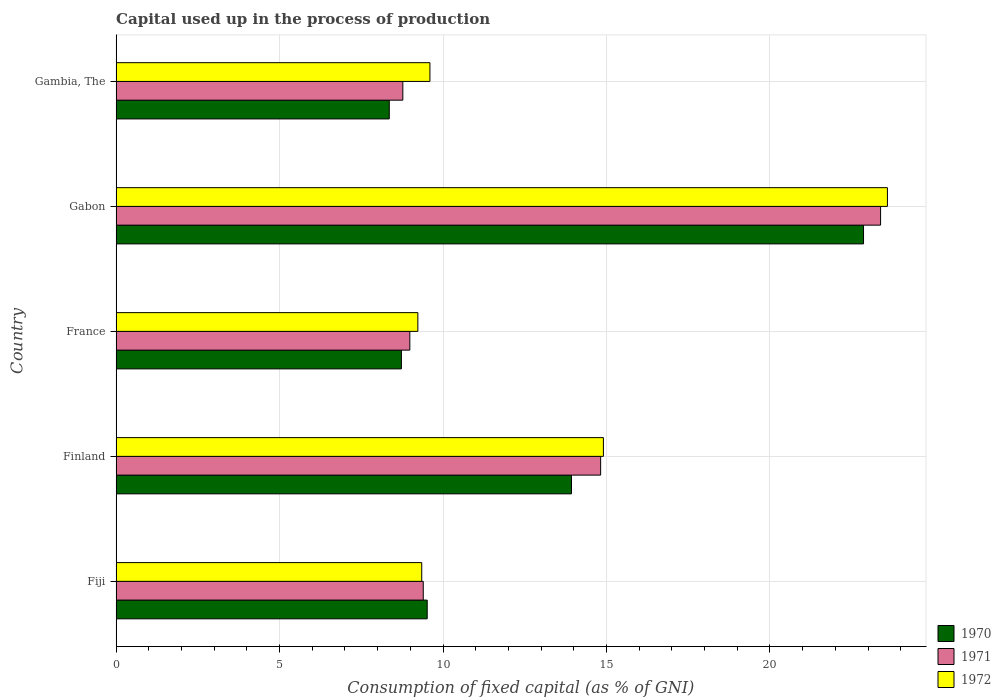How many different coloured bars are there?
Give a very brief answer. 3. Are the number of bars on each tick of the Y-axis equal?
Your response must be concise. Yes. How many bars are there on the 4th tick from the top?
Your response must be concise. 3. What is the label of the 5th group of bars from the top?
Your answer should be compact. Fiji. What is the capital used up in the process of production in 1971 in Gambia, The?
Your answer should be very brief. 8.77. Across all countries, what is the maximum capital used up in the process of production in 1970?
Keep it short and to the point. 22.86. Across all countries, what is the minimum capital used up in the process of production in 1972?
Give a very brief answer. 9.23. In which country was the capital used up in the process of production in 1970 maximum?
Make the answer very short. Gabon. In which country was the capital used up in the process of production in 1972 minimum?
Provide a short and direct response. France. What is the total capital used up in the process of production in 1971 in the graph?
Ensure brevity in your answer.  65.35. What is the difference between the capital used up in the process of production in 1970 in Fiji and that in Finland?
Provide a short and direct response. -4.41. What is the difference between the capital used up in the process of production in 1972 in Gabon and the capital used up in the process of production in 1970 in Finland?
Offer a very short reply. 9.66. What is the average capital used up in the process of production in 1970 per country?
Make the answer very short. 12.68. What is the difference between the capital used up in the process of production in 1972 and capital used up in the process of production in 1971 in Finland?
Ensure brevity in your answer.  0.08. In how many countries, is the capital used up in the process of production in 1972 greater than 2 %?
Keep it short and to the point. 5. What is the ratio of the capital used up in the process of production in 1971 in Finland to that in France?
Offer a very short reply. 1.65. What is the difference between the highest and the second highest capital used up in the process of production in 1970?
Make the answer very short. 8.93. What is the difference between the highest and the lowest capital used up in the process of production in 1972?
Your answer should be very brief. 14.36. Is the sum of the capital used up in the process of production in 1971 in Finland and Gabon greater than the maximum capital used up in the process of production in 1972 across all countries?
Make the answer very short. Yes. What does the 3rd bar from the bottom in Gabon represents?
Keep it short and to the point. 1972. Is it the case that in every country, the sum of the capital used up in the process of production in 1970 and capital used up in the process of production in 1972 is greater than the capital used up in the process of production in 1971?
Give a very brief answer. Yes. Are all the bars in the graph horizontal?
Your answer should be compact. Yes. Does the graph contain any zero values?
Your answer should be compact. No. Does the graph contain grids?
Make the answer very short. Yes. Where does the legend appear in the graph?
Give a very brief answer. Bottom right. How many legend labels are there?
Your answer should be very brief. 3. How are the legend labels stacked?
Your answer should be compact. Vertical. What is the title of the graph?
Make the answer very short. Capital used up in the process of production. What is the label or title of the X-axis?
Make the answer very short. Consumption of fixed capital (as % of GNI). What is the label or title of the Y-axis?
Ensure brevity in your answer.  Country. What is the Consumption of fixed capital (as % of GNI) of 1970 in Fiji?
Offer a terse response. 9.52. What is the Consumption of fixed capital (as % of GNI) of 1971 in Fiji?
Ensure brevity in your answer.  9.39. What is the Consumption of fixed capital (as % of GNI) of 1972 in Fiji?
Your answer should be very brief. 9.35. What is the Consumption of fixed capital (as % of GNI) of 1970 in Finland?
Offer a terse response. 13.93. What is the Consumption of fixed capital (as % of GNI) of 1971 in Finland?
Your answer should be compact. 14.82. What is the Consumption of fixed capital (as % of GNI) of 1972 in Finland?
Your answer should be compact. 14.9. What is the Consumption of fixed capital (as % of GNI) of 1970 in France?
Make the answer very short. 8.73. What is the Consumption of fixed capital (as % of GNI) of 1971 in France?
Make the answer very short. 8.98. What is the Consumption of fixed capital (as % of GNI) of 1972 in France?
Give a very brief answer. 9.23. What is the Consumption of fixed capital (as % of GNI) of 1970 in Gabon?
Your response must be concise. 22.86. What is the Consumption of fixed capital (as % of GNI) in 1971 in Gabon?
Your response must be concise. 23.38. What is the Consumption of fixed capital (as % of GNI) of 1972 in Gabon?
Make the answer very short. 23.59. What is the Consumption of fixed capital (as % of GNI) in 1970 in Gambia, The?
Offer a very short reply. 8.35. What is the Consumption of fixed capital (as % of GNI) of 1971 in Gambia, The?
Provide a succinct answer. 8.77. What is the Consumption of fixed capital (as % of GNI) of 1972 in Gambia, The?
Keep it short and to the point. 9.6. Across all countries, what is the maximum Consumption of fixed capital (as % of GNI) of 1970?
Give a very brief answer. 22.86. Across all countries, what is the maximum Consumption of fixed capital (as % of GNI) of 1971?
Your answer should be very brief. 23.38. Across all countries, what is the maximum Consumption of fixed capital (as % of GNI) of 1972?
Ensure brevity in your answer.  23.59. Across all countries, what is the minimum Consumption of fixed capital (as % of GNI) in 1970?
Make the answer very short. 8.35. Across all countries, what is the minimum Consumption of fixed capital (as % of GNI) in 1971?
Your answer should be compact. 8.77. Across all countries, what is the minimum Consumption of fixed capital (as % of GNI) of 1972?
Give a very brief answer. 9.23. What is the total Consumption of fixed capital (as % of GNI) of 1970 in the graph?
Make the answer very short. 63.39. What is the total Consumption of fixed capital (as % of GNI) of 1971 in the graph?
Make the answer very short. 65.35. What is the total Consumption of fixed capital (as % of GNI) in 1972 in the graph?
Give a very brief answer. 66.67. What is the difference between the Consumption of fixed capital (as % of GNI) in 1970 in Fiji and that in Finland?
Provide a succinct answer. -4.41. What is the difference between the Consumption of fixed capital (as % of GNI) of 1971 in Fiji and that in Finland?
Ensure brevity in your answer.  -5.43. What is the difference between the Consumption of fixed capital (as % of GNI) of 1972 in Fiji and that in Finland?
Make the answer very short. -5.56. What is the difference between the Consumption of fixed capital (as % of GNI) in 1970 in Fiji and that in France?
Provide a succinct answer. 0.79. What is the difference between the Consumption of fixed capital (as % of GNI) in 1971 in Fiji and that in France?
Offer a terse response. 0.41. What is the difference between the Consumption of fixed capital (as % of GNI) of 1972 in Fiji and that in France?
Provide a succinct answer. 0.12. What is the difference between the Consumption of fixed capital (as % of GNI) in 1970 in Fiji and that in Gabon?
Offer a terse response. -13.35. What is the difference between the Consumption of fixed capital (as % of GNI) of 1971 in Fiji and that in Gabon?
Offer a very short reply. -13.99. What is the difference between the Consumption of fixed capital (as % of GNI) in 1972 in Fiji and that in Gabon?
Make the answer very short. -14.24. What is the difference between the Consumption of fixed capital (as % of GNI) in 1970 in Fiji and that in Gambia, The?
Your answer should be compact. 1.16. What is the difference between the Consumption of fixed capital (as % of GNI) of 1971 in Fiji and that in Gambia, The?
Offer a terse response. 0.62. What is the difference between the Consumption of fixed capital (as % of GNI) in 1972 in Fiji and that in Gambia, The?
Give a very brief answer. -0.25. What is the difference between the Consumption of fixed capital (as % of GNI) in 1970 in Finland and that in France?
Your response must be concise. 5.2. What is the difference between the Consumption of fixed capital (as % of GNI) of 1971 in Finland and that in France?
Your answer should be very brief. 5.84. What is the difference between the Consumption of fixed capital (as % of GNI) of 1972 in Finland and that in France?
Keep it short and to the point. 5.68. What is the difference between the Consumption of fixed capital (as % of GNI) of 1970 in Finland and that in Gabon?
Give a very brief answer. -8.93. What is the difference between the Consumption of fixed capital (as % of GNI) of 1971 in Finland and that in Gabon?
Offer a very short reply. -8.56. What is the difference between the Consumption of fixed capital (as % of GNI) of 1972 in Finland and that in Gabon?
Keep it short and to the point. -8.69. What is the difference between the Consumption of fixed capital (as % of GNI) of 1970 in Finland and that in Gambia, The?
Your response must be concise. 5.57. What is the difference between the Consumption of fixed capital (as % of GNI) of 1971 in Finland and that in Gambia, The?
Your response must be concise. 6.05. What is the difference between the Consumption of fixed capital (as % of GNI) in 1972 in Finland and that in Gambia, The?
Provide a succinct answer. 5.31. What is the difference between the Consumption of fixed capital (as % of GNI) of 1970 in France and that in Gabon?
Your answer should be compact. -14.14. What is the difference between the Consumption of fixed capital (as % of GNI) in 1971 in France and that in Gabon?
Provide a short and direct response. -14.4. What is the difference between the Consumption of fixed capital (as % of GNI) of 1972 in France and that in Gabon?
Provide a succinct answer. -14.36. What is the difference between the Consumption of fixed capital (as % of GNI) of 1970 in France and that in Gambia, The?
Make the answer very short. 0.37. What is the difference between the Consumption of fixed capital (as % of GNI) in 1971 in France and that in Gambia, The?
Provide a short and direct response. 0.21. What is the difference between the Consumption of fixed capital (as % of GNI) in 1972 in France and that in Gambia, The?
Give a very brief answer. -0.37. What is the difference between the Consumption of fixed capital (as % of GNI) of 1970 in Gabon and that in Gambia, The?
Your answer should be very brief. 14.51. What is the difference between the Consumption of fixed capital (as % of GNI) in 1971 in Gabon and that in Gambia, The?
Provide a short and direct response. 14.61. What is the difference between the Consumption of fixed capital (as % of GNI) in 1972 in Gabon and that in Gambia, The?
Offer a very short reply. 13.99. What is the difference between the Consumption of fixed capital (as % of GNI) of 1970 in Fiji and the Consumption of fixed capital (as % of GNI) of 1971 in Finland?
Your answer should be very brief. -5.3. What is the difference between the Consumption of fixed capital (as % of GNI) of 1970 in Fiji and the Consumption of fixed capital (as % of GNI) of 1972 in Finland?
Ensure brevity in your answer.  -5.39. What is the difference between the Consumption of fixed capital (as % of GNI) of 1971 in Fiji and the Consumption of fixed capital (as % of GNI) of 1972 in Finland?
Your answer should be very brief. -5.51. What is the difference between the Consumption of fixed capital (as % of GNI) in 1970 in Fiji and the Consumption of fixed capital (as % of GNI) in 1971 in France?
Give a very brief answer. 0.53. What is the difference between the Consumption of fixed capital (as % of GNI) of 1970 in Fiji and the Consumption of fixed capital (as % of GNI) of 1972 in France?
Offer a very short reply. 0.29. What is the difference between the Consumption of fixed capital (as % of GNI) of 1971 in Fiji and the Consumption of fixed capital (as % of GNI) of 1972 in France?
Your answer should be compact. 0.17. What is the difference between the Consumption of fixed capital (as % of GNI) in 1970 in Fiji and the Consumption of fixed capital (as % of GNI) in 1971 in Gabon?
Offer a very short reply. -13.87. What is the difference between the Consumption of fixed capital (as % of GNI) in 1970 in Fiji and the Consumption of fixed capital (as % of GNI) in 1972 in Gabon?
Give a very brief answer. -14.08. What is the difference between the Consumption of fixed capital (as % of GNI) in 1971 in Fiji and the Consumption of fixed capital (as % of GNI) in 1972 in Gabon?
Ensure brevity in your answer.  -14.2. What is the difference between the Consumption of fixed capital (as % of GNI) in 1970 in Fiji and the Consumption of fixed capital (as % of GNI) in 1971 in Gambia, The?
Provide a succinct answer. 0.75. What is the difference between the Consumption of fixed capital (as % of GNI) in 1970 in Fiji and the Consumption of fixed capital (as % of GNI) in 1972 in Gambia, The?
Make the answer very short. -0.08. What is the difference between the Consumption of fixed capital (as % of GNI) in 1971 in Fiji and the Consumption of fixed capital (as % of GNI) in 1972 in Gambia, The?
Ensure brevity in your answer.  -0.2. What is the difference between the Consumption of fixed capital (as % of GNI) in 1970 in Finland and the Consumption of fixed capital (as % of GNI) in 1971 in France?
Provide a succinct answer. 4.94. What is the difference between the Consumption of fixed capital (as % of GNI) of 1970 in Finland and the Consumption of fixed capital (as % of GNI) of 1972 in France?
Provide a succinct answer. 4.7. What is the difference between the Consumption of fixed capital (as % of GNI) of 1971 in Finland and the Consumption of fixed capital (as % of GNI) of 1972 in France?
Ensure brevity in your answer.  5.59. What is the difference between the Consumption of fixed capital (as % of GNI) in 1970 in Finland and the Consumption of fixed capital (as % of GNI) in 1971 in Gabon?
Provide a succinct answer. -9.46. What is the difference between the Consumption of fixed capital (as % of GNI) in 1970 in Finland and the Consumption of fixed capital (as % of GNI) in 1972 in Gabon?
Make the answer very short. -9.66. What is the difference between the Consumption of fixed capital (as % of GNI) of 1971 in Finland and the Consumption of fixed capital (as % of GNI) of 1972 in Gabon?
Your answer should be compact. -8.77. What is the difference between the Consumption of fixed capital (as % of GNI) of 1970 in Finland and the Consumption of fixed capital (as % of GNI) of 1971 in Gambia, The?
Keep it short and to the point. 5.16. What is the difference between the Consumption of fixed capital (as % of GNI) of 1970 in Finland and the Consumption of fixed capital (as % of GNI) of 1972 in Gambia, The?
Offer a very short reply. 4.33. What is the difference between the Consumption of fixed capital (as % of GNI) in 1971 in Finland and the Consumption of fixed capital (as % of GNI) in 1972 in Gambia, The?
Give a very brief answer. 5.22. What is the difference between the Consumption of fixed capital (as % of GNI) in 1970 in France and the Consumption of fixed capital (as % of GNI) in 1971 in Gabon?
Offer a terse response. -14.66. What is the difference between the Consumption of fixed capital (as % of GNI) of 1970 in France and the Consumption of fixed capital (as % of GNI) of 1972 in Gabon?
Make the answer very short. -14.87. What is the difference between the Consumption of fixed capital (as % of GNI) in 1971 in France and the Consumption of fixed capital (as % of GNI) in 1972 in Gabon?
Offer a terse response. -14.61. What is the difference between the Consumption of fixed capital (as % of GNI) in 1970 in France and the Consumption of fixed capital (as % of GNI) in 1971 in Gambia, The?
Ensure brevity in your answer.  -0.04. What is the difference between the Consumption of fixed capital (as % of GNI) of 1970 in France and the Consumption of fixed capital (as % of GNI) of 1972 in Gambia, The?
Make the answer very short. -0.87. What is the difference between the Consumption of fixed capital (as % of GNI) in 1971 in France and the Consumption of fixed capital (as % of GNI) in 1972 in Gambia, The?
Your response must be concise. -0.61. What is the difference between the Consumption of fixed capital (as % of GNI) of 1970 in Gabon and the Consumption of fixed capital (as % of GNI) of 1971 in Gambia, The?
Provide a short and direct response. 14.09. What is the difference between the Consumption of fixed capital (as % of GNI) of 1970 in Gabon and the Consumption of fixed capital (as % of GNI) of 1972 in Gambia, The?
Give a very brief answer. 13.26. What is the difference between the Consumption of fixed capital (as % of GNI) of 1971 in Gabon and the Consumption of fixed capital (as % of GNI) of 1972 in Gambia, The?
Your response must be concise. 13.78. What is the average Consumption of fixed capital (as % of GNI) in 1970 per country?
Your answer should be very brief. 12.68. What is the average Consumption of fixed capital (as % of GNI) of 1971 per country?
Offer a terse response. 13.07. What is the average Consumption of fixed capital (as % of GNI) in 1972 per country?
Make the answer very short. 13.33. What is the difference between the Consumption of fixed capital (as % of GNI) of 1970 and Consumption of fixed capital (as % of GNI) of 1971 in Fiji?
Offer a terse response. 0.12. What is the difference between the Consumption of fixed capital (as % of GNI) of 1970 and Consumption of fixed capital (as % of GNI) of 1972 in Fiji?
Your answer should be very brief. 0.17. What is the difference between the Consumption of fixed capital (as % of GNI) in 1971 and Consumption of fixed capital (as % of GNI) in 1972 in Fiji?
Ensure brevity in your answer.  0.05. What is the difference between the Consumption of fixed capital (as % of GNI) of 1970 and Consumption of fixed capital (as % of GNI) of 1971 in Finland?
Your response must be concise. -0.89. What is the difference between the Consumption of fixed capital (as % of GNI) in 1970 and Consumption of fixed capital (as % of GNI) in 1972 in Finland?
Provide a short and direct response. -0.98. What is the difference between the Consumption of fixed capital (as % of GNI) in 1971 and Consumption of fixed capital (as % of GNI) in 1972 in Finland?
Your answer should be compact. -0.08. What is the difference between the Consumption of fixed capital (as % of GNI) of 1970 and Consumption of fixed capital (as % of GNI) of 1971 in France?
Your answer should be compact. -0.26. What is the difference between the Consumption of fixed capital (as % of GNI) in 1970 and Consumption of fixed capital (as % of GNI) in 1972 in France?
Keep it short and to the point. -0.5. What is the difference between the Consumption of fixed capital (as % of GNI) in 1971 and Consumption of fixed capital (as % of GNI) in 1972 in France?
Your response must be concise. -0.25. What is the difference between the Consumption of fixed capital (as % of GNI) of 1970 and Consumption of fixed capital (as % of GNI) of 1971 in Gabon?
Your answer should be very brief. -0.52. What is the difference between the Consumption of fixed capital (as % of GNI) of 1970 and Consumption of fixed capital (as % of GNI) of 1972 in Gabon?
Make the answer very short. -0.73. What is the difference between the Consumption of fixed capital (as % of GNI) in 1971 and Consumption of fixed capital (as % of GNI) in 1972 in Gabon?
Your answer should be compact. -0.21. What is the difference between the Consumption of fixed capital (as % of GNI) in 1970 and Consumption of fixed capital (as % of GNI) in 1971 in Gambia, The?
Offer a terse response. -0.41. What is the difference between the Consumption of fixed capital (as % of GNI) in 1970 and Consumption of fixed capital (as % of GNI) in 1972 in Gambia, The?
Your answer should be very brief. -1.24. What is the difference between the Consumption of fixed capital (as % of GNI) of 1971 and Consumption of fixed capital (as % of GNI) of 1972 in Gambia, The?
Your answer should be very brief. -0.83. What is the ratio of the Consumption of fixed capital (as % of GNI) of 1970 in Fiji to that in Finland?
Provide a succinct answer. 0.68. What is the ratio of the Consumption of fixed capital (as % of GNI) of 1971 in Fiji to that in Finland?
Keep it short and to the point. 0.63. What is the ratio of the Consumption of fixed capital (as % of GNI) of 1972 in Fiji to that in Finland?
Ensure brevity in your answer.  0.63. What is the ratio of the Consumption of fixed capital (as % of GNI) in 1970 in Fiji to that in France?
Your answer should be very brief. 1.09. What is the ratio of the Consumption of fixed capital (as % of GNI) in 1971 in Fiji to that in France?
Provide a succinct answer. 1.05. What is the ratio of the Consumption of fixed capital (as % of GNI) in 1972 in Fiji to that in France?
Provide a succinct answer. 1.01. What is the ratio of the Consumption of fixed capital (as % of GNI) in 1970 in Fiji to that in Gabon?
Keep it short and to the point. 0.42. What is the ratio of the Consumption of fixed capital (as % of GNI) in 1971 in Fiji to that in Gabon?
Ensure brevity in your answer.  0.4. What is the ratio of the Consumption of fixed capital (as % of GNI) in 1972 in Fiji to that in Gabon?
Ensure brevity in your answer.  0.4. What is the ratio of the Consumption of fixed capital (as % of GNI) in 1970 in Fiji to that in Gambia, The?
Provide a short and direct response. 1.14. What is the ratio of the Consumption of fixed capital (as % of GNI) of 1971 in Fiji to that in Gambia, The?
Ensure brevity in your answer.  1.07. What is the ratio of the Consumption of fixed capital (as % of GNI) in 1972 in Fiji to that in Gambia, The?
Provide a succinct answer. 0.97. What is the ratio of the Consumption of fixed capital (as % of GNI) of 1970 in Finland to that in France?
Provide a succinct answer. 1.6. What is the ratio of the Consumption of fixed capital (as % of GNI) of 1971 in Finland to that in France?
Make the answer very short. 1.65. What is the ratio of the Consumption of fixed capital (as % of GNI) in 1972 in Finland to that in France?
Provide a succinct answer. 1.61. What is the ratio of the Consumption of fixed capital (as % of GNI) of 1970 in Finland to that in Gabon?
Make the answer very short. 0.61. What is the ratio of the Consumption of fixed capital (as % of GNI) in 1971 in Finland to that in Gabon?
Provide a short and direct response. 0.63. What is the ratio of the Consumption of fixed capital (as % of GNI) in 1972 in Finland to that in Gabon?
Keep it short and to the point. 0.63. What is the ratio of the Consumption of fixed capital (as % of GNI) in 1970 in Finland to that in Gambia, The?
Offer a terse response. 1.67. What is the ratio of the Consumption of fixed capital (as % of GNI) of 1971 in Finland to that in Gambia, The?
Provide a succinct answer. 1.69. What is the ratio of the Consumption of fixed capital (as % of GNI) in 1972 in Finland to that in Gambia, The?
Your answer should be compact. 1.55. What is the ratio of the Consumption of fixed capital (as % of GNI) of 1970 in France to that in Gabon?
Give a very brief answer. 0.38. What is the ratio of the Consumption of fixed capital (as % of GNI) in 1971 in France to that in Gabon?
Provide a short and direct response. 0.38. What is the ratio of the Consumption of fixed capital (as % of GNI) in 1972 in France to that in Gabon?
Give a very brief answer. 0.39. What is the ratio of the Consumption of fixed capital (as % of GNI) of 1970 in France to that in Gambia, The?
Give a very brief answer. 1.04. What is the ratio of the Consumption of fixed capital (as % of GNI) of 1971 in France to that in Gambia, The?
Give a very brief answer. 1.02. What is the ratio of the Consumption of fixed capital (as % of GNI) in 1972 in France to that in Gambia, The?
Offer a terse response. 0.96. What is the ratio of the Consumption of fixed capital (as % of GNI) in 1970 in Gabon to that in Gambia, The?
Offer a very short reply. 2.74. What is the ratio of the Consumption of fixed capital (as % of GNI) in 1971 in Gabon to that in Gambia, The?
Provide a succinct answer. 2.67. What is the ratio of the Consumption of fixed capital (as % of GNI) of 1972 in Gabon to that in Gambia, The?
Your answer should be very brief. 2.46. What is the difference between the highest and the second highest Consumption of fixed capital (as % of GNI) of 1970?
Offer a very short reply. 8.93. What is the difference between the highest and the second highest Consumption of fixed capital (as % of GNI) of 1971?
Keep it short and to the point. 8.56. What is the difference between the highest and the second highest Consumption of fixed capital (as % of GNI) in 1972?
Keep it short and to the point. 8.69. What is the difference between the highest and the lowest Consumption of fixed capital (as % of GNI) in 1970?
Offer a very short reply. 14.51. What is the difference between the highest and the lowest Consumption of fixed capital (as % of GNI) of 1971?
Provide a short and direct response. 14.61. What is the difference between the highest and the lowest Consumption of fixed capital (as % of GNI) of 1972?
Offer a terse response. 14.36. 